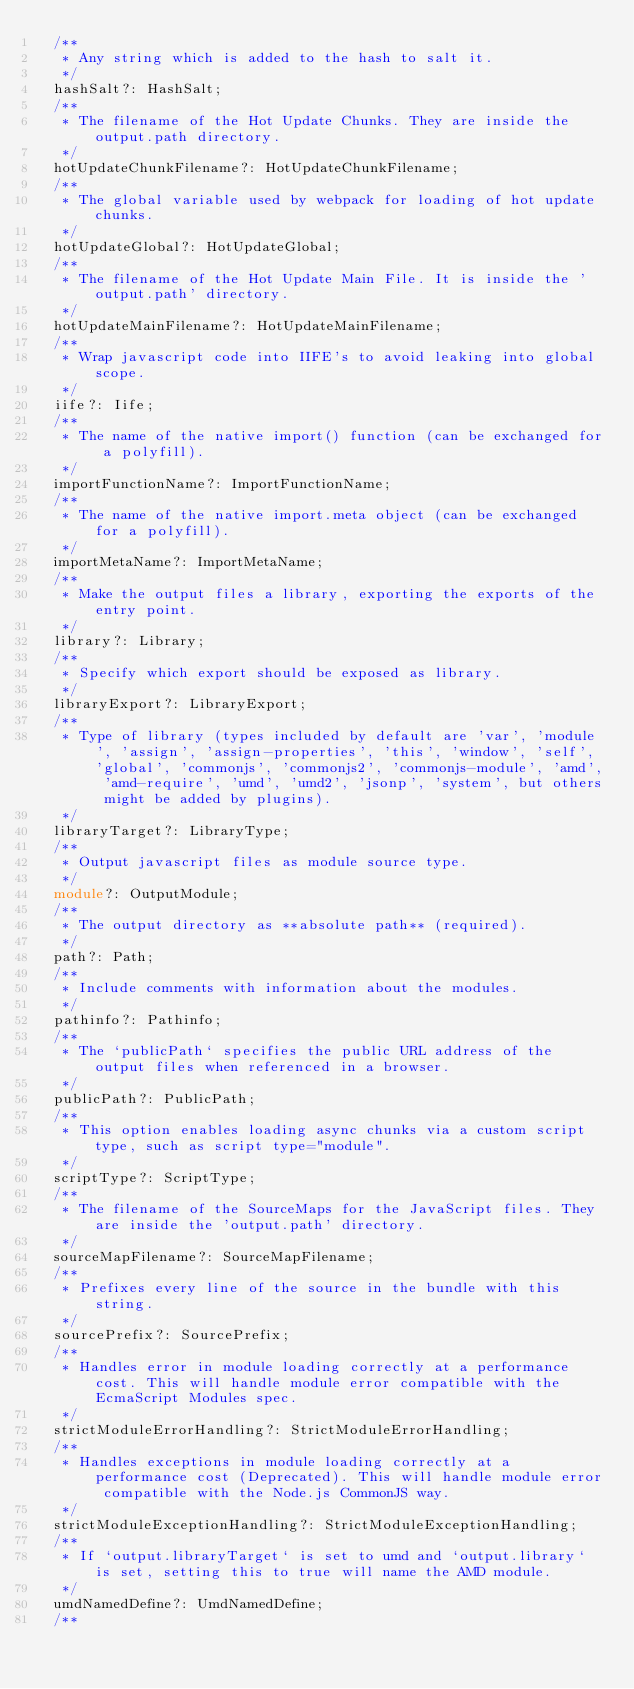<code> <loc_0><loc_0><loc_500><loc_500><_TypeScript_>	/**
	 * Any string which is added to the hash to salt it.
	 */
	hashSalt?: HashSalt;
	/**
	 * The filename of the Hot Update Chunks. They are inside the output.path directory.
	 */
	hotUpdateChunkFilename?: HotUpdateChunkFilename;
	/**
	 * The global variable used by webpack for loading of hot update chunks.
	 */
	hotUpdateGlobal?: HotUpdateGlobal;
	/**
	 * The filename of the Hot Update Main File. It is inside the 'output.path' directory.
	 */
	hotUpdateMainFilename?: HotUpdateMainFilename;
	/**
	 * Wrap javascript code into IIFE's to avoid leaking into global scope.
	 */
	iife?: Iife;
	/**
	 * The name of the native import() function (can be exchanged for a polyfill).
	 */
	importFunctionName?: ImportFunctionName;
	/**
	 * The name of the native import.meta object (can be exchanged for a polyfill).
	 */
	importMetaName?: ImportMetaName;
	/**
	 * Make the output files a library, exporting the exports of the entry point.
	 */
	library?: Library;
	/**
	 * Specify which export should be exposed as library.
	 */
	libraryExport?: LibraryExport;
	/**
	 * Type of library (types included by default are 'var', 'module', 'assign', 'assign-properties', 'this', 'window', 'self', 'global', 'commonjs', 'commonjs2', 'commonjs-module', 'amd', 'amd-require', 'umd', 'umd2', 'jsonp', 'system', but others might be added by plugins).
	 */
	libraryTarget?: LibraryType;
	/**
	 * Output javascript files as module source type.
	 */
	module?: OutputModule;
	/**
	 * The output directory as **absolute path** (required).
	 */
	path?: Path;
	/**
	 * Include comments with information about the modules.
	 */
	pathinfo?: Pathinfo;
	/**
	 * The `publicPath` specifies the public URL address of the output files when referenced in a browser.
	 */
	publicPath?: PublicPath;
	/**
	 * This option enables loading async chunks via a custom script type, such as script type="module".
	 */
	scriptType?: ScriptType;
	/**
	 * The filename of the SourceMaps for the JavaScript files. They are inside the 'output.path' directory.
	 */
	sourceMapFilename?: SourceMapFilename;
	/**
	 * Prefixes every line of the source in the bundle with this string.
	 */
	sourcePrefix?: SourcePrefix;
	/**
	 * Handles error in module loading correctly at a performance cost. This will handle module error compatible with the EcmaScript Modules spec.
	 */
	strictModuleErrorHandling?: StrictModuleErrorHandling;
	/**
	 * Handles exceptions in module loading correctly at a performance cost (Deprecated). This will handle module error compatible with the Node.js CommonJS way.
	 */
	strictModuleExceptionHandling?: StrictModuleExceptionHandling;
	/**
	 * If `output.libraryTarget` is set to umd and `output.library` is set, setting this to true will name the AMD module.
	 */
	umdNamedDefine?: UmdNamedDefine;
	/**</code> 